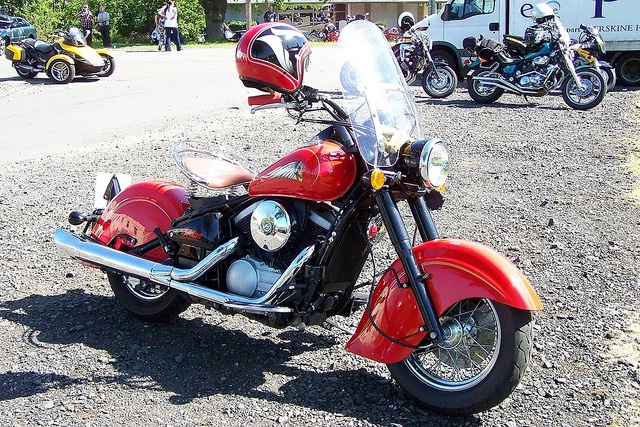Describe the objects in this image and their specific colors. I can see motorcycle in darkgreen, black, white, brown, and gray tones, truck in darkgreen, lightblue, black, and navy tones, motorcycle in darkgreen, black, lightgray, gray, and navy tones, motorcycle in darkgreen, black, white, gray, and darkgray tones, and motorcycle in darkgreen, black, lightgray, gray, and darkgray tones in this image. 